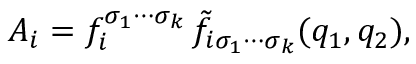<formula> <loc_0><loc_0><loc_500><loc_500>A _ { i } = f _ { i } ^ { \sigma _ { 1 } \cdots \sigma _ { k } } \, \tilde { f } _ { i \sigma _ { 1 } \cdots \sigma _ { k } } ( q _ { 1 } , q _ { 2 } ) ,</formula> 